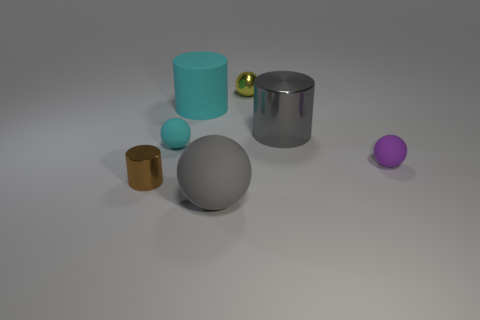Add 2 tiny shiny cylinders. How many objects exist? 9 Subtract all balls. How many objects are left? 3 Subtract 0 green blocks. How many objects are left? 7 Subtract all yellow metallic spheres. Subtract all small cyan matte things. How many objects are left? 5 Add 3 matte cylinders. How many matte cylinders are left? 4 Add 1 tiny rubber things. How many tiny rubber things exist? 3 